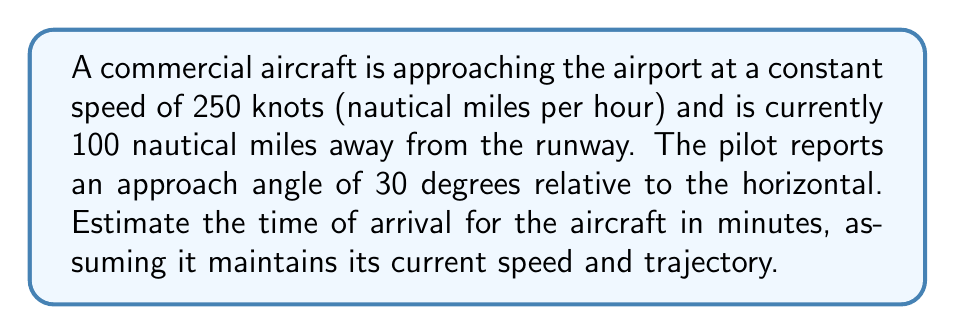Solve this math problem. To solve this problem, we'll use trigonometry and basic physics concepts. Let's break it down step-by-step:

1) First, we need to calculate the direct distance to the runway. We're given the hypotenuse of the triangle (100 nautical miles) and the angle (30 degrees).

2) The direct distance to the runway is the adjacent side of the right triangle. We can find this using the cosine function:

   $\cos(30°) = \frac{\text{adjacent}}{\text{hypotenuse}}$

   $\text{adjacent} = 100 \cdot \cos(30°)$

3) Let's calculate this:
   
   $\text{adjacent} = 100 \cdot \cos(30°) = 100 \cdot \frac{\sqrt{3}}{2} \approx 86.6$ nautical miles

4) Now that we have the distance, we can use the speed to calculate the time:

   $\text{Time} = \frac{\text{Distance}}{\text{Speed}}$

5) Plugging in our values:

   $\text{Time} = \frac{86.6 \text{ nautical miles}}{250 \text{ knots}}$

6) Simplify:

   $\text{Time} = 0.3464 \text{ hours}$

7) Convert to minutes:

   $\text{Time in minutes} = 0.3464 \cdot 60 = 20.784 \text{ minutes}$

8) Rounding to the nearest minute:

   $\text{Estimated time of arrival} \approx 21 \text{ minutes}$
Answer: 21 minutes 